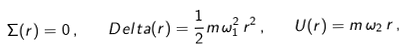Convert formula to latex. <formula><loc_0><loc_0><loc_500><loc_500>\Sigma ( r ) = 0 \, , \quad D e l t a ( r ) = \frac { 1 } { 2 } m \, \omega _ { 1 } ^ { 2 } \, r ^ { 2 } \, , \quad U ( r ) = m \, \omega _ { 2 } \, r \, ,</formula> 